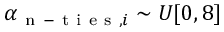<formula> <loc_0><loc_0><loc_500><loc_500>\alpha _ { n - t i e s , i } \sim U [ 0 , 8 ]</formula> 